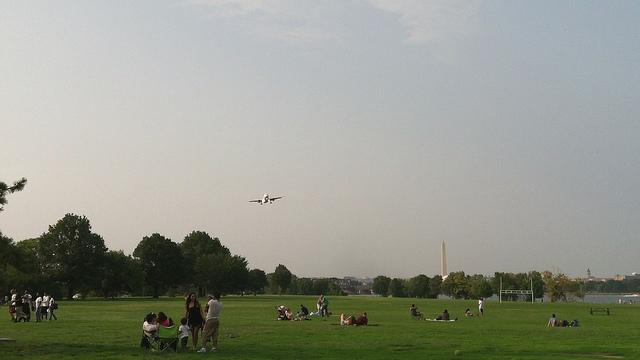What color is the grass?
Quick response, please. Green. What are they flying?
Write a very short answer. Airplane. What is soaring in the sky?
Write a very short answer. Plane. What can you see in the sky?
Answer briefly. Plane. Is this a real plane?
Answer briefly. Yes. How many airplanes are visible?
Quick response, please. 1. Is there a bottled water in the picture?
Short answer required. No. How many people?
Answer briefly. 15. What city is this near?
Quick response, please. Washington dc. Is this a public park?
Keep it brief. Yes. Are this planes flying in formation?
Quick response, please. No. What's on the sky?
Concise answer only. Plane. What is the bright object in the sky?
Concise answer only. Plane. What color is the sky?
Concise answer only. Gray. Does this look like an organized event?
Answer briefly. No. Are there more than two people in the picture?
Write a very short answer. Yes. What object is the man flying?
Short answer required. Plane. What is in the sky?
Write a very short answer. Plane. 